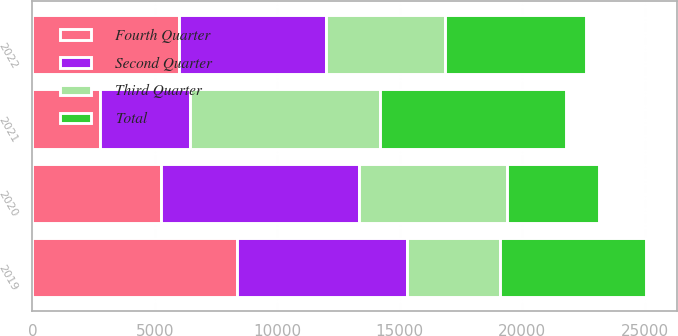Convert chart to OTSL. <chart><loc_0><loc_0><loc_500><loc_500><stacked_bar_chart><ecel><fcel>2019<fcel>2020<fcel>2021<fcel>2022<nl><fcel>Fourth Quarter<fcel>8354<fcel>5264<fcel>2772<fcel>5998<nl><fcel>Second Quarter<fcel>6927<fcel>8071<fcel>3651<fcel>5991<nl><fcel>Third Quarter<fcel>3806<fcel>6039<fcel>7757<fcel>4869<nl><fcel>Total<fcel>5991<fcel>3746<fcel>7601<fcel>5744<nl></chart> 